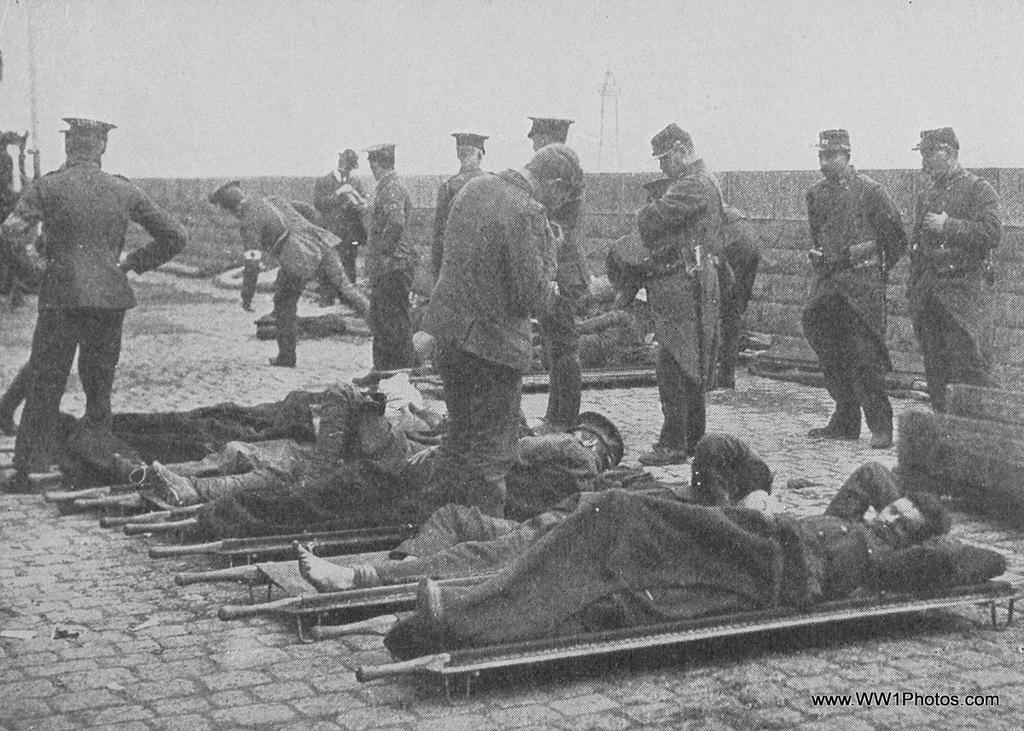How would you summarize this image in a sentence or two? In this image I can see there are few persons lying on bed and some persons standing on floor, in the middle there is the wall ,at the top there is the sky visible, this is an old picture , in the bottom right I can see text. 